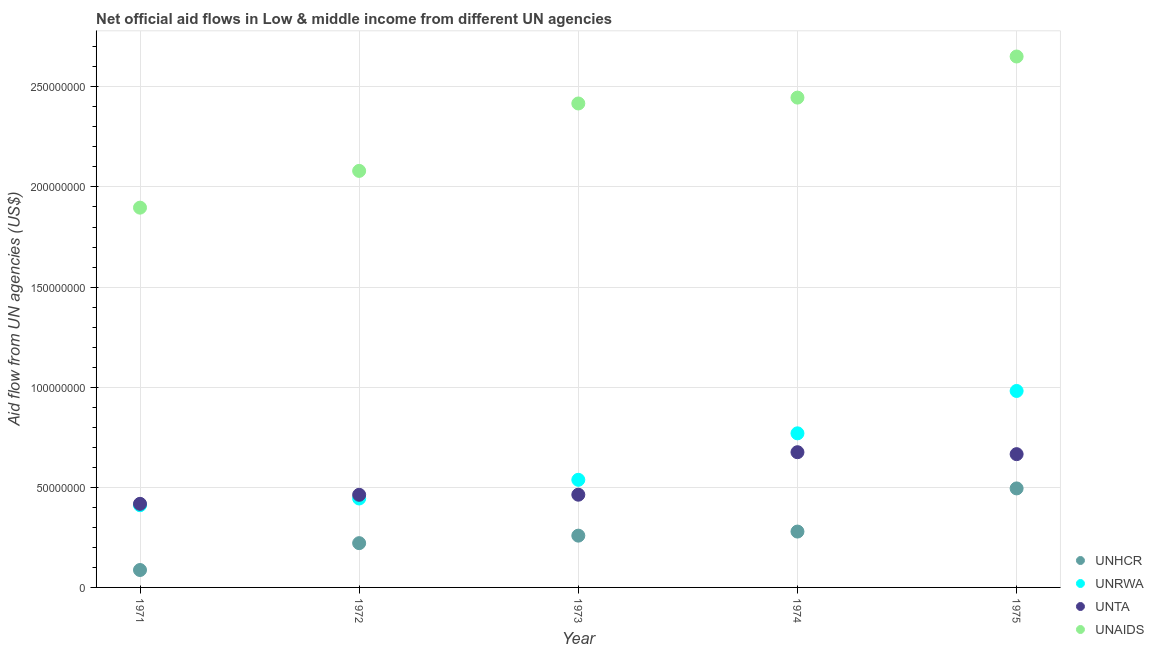How many different coloured dotlines are there?
Make the answer very short. 4. Is the number of dotlines equal to the number of legend labels?
Make the answer very short. Yes. What is the amount of aid given by unaids in 1975?
Keep it short and to the point. 2.65e+08. Across all years, what is the maximum amount of aid given by unrwa?
Your answer should be compact. 9.81e+07. Across all years, what is the minimum amount of aid given by unhcr?
Keep it short and to the point. 8.70e+06. In which year was the amount of aid given by unhcr maximum?
Your response must be concise. 1975. In which year was the amount of aid given by unhcr minimum?
Your response must be concise. 1971. What is the total amount of aid given by unhcr in the graph?
Your response must be concise. 1.34e+08. What is the difference between the amount of aid given by unaids in 1971 and that in 1974?
Make the answer very short. -5.50e+07. What is the difference between the amount of aid given by unrwa in 1975 and the amount of aid given by unhcr in 1972?
Offer a terse response. 7.60e+07. What is the average amount of aid given by unta per year?
Your answer should be very brief. 5.37e+07. In the year 1971, what is the difference between the amount of aid given by unhcr and amount of aid given by unrwa?
Give a very brief answer. -3.24e+07. In how many years, is the amount of aid given by unta greater than 50000000 US$?
Your answer should be very brief. 2. What is the ratio of the amount of aid given by unaids in 1973 to that in 1974?
Provide a short and direct response. 0.99. Is the amount of aid given by unhcr in 1972 less than that in 1973?
Ensure brevity in your answer.  Yes. What is the difference between the highest and the second highest amount of aid given by unhcr?
Your answer should be very brief. 2.16e+07. What is the difference between the highest and the lowest amount of aid given by unaids?
Offer a very short reply. 7.55e+07. In how many years, is the amount of aid given by unta greater than the average amount of aid given by unta taken over all years?
Your answer should be compact. 2. Is it the case that in every year, the sum of the amount of aid given by unhcr and amount of aid given by unrwa is greater than the sum of amount of aid given by unta and amount of aid given by unaids?
Ensure brevity in your answer.  No. Is the amount of aid given by unaids strictly greater than the amount of aid given by unrwa over the years?
Your answer should be very brief. Yes. Is the amount of aid given by unhcr strictly less than the amount of aid given by unta over the years?
Offer a very short reply. Yes. How many dotlines are there?
Offer a very short reply. 4. How many years are there in the graph?
Offer a very short reply. 5. What is the difference between two consecutive major ticks on the Y-axis?
Ensure brevity in your answer.  5.00e+07. Are the values on the major ticks of Y-axis written in scientific E-notation?
Your answer should be very brief. No. Where does the legend appear in the graph?
Offer a very short reply. Bottom right. How many legend labels are there?
Give a very brief answer. 4. How are the legend labels stacked?
Your response must be concise. Vertical. What is the title of the graph?
Keep it short and to the point. Net official aid flows in Low & middle income from different UN agencies. Does "Compensation of employees" appear as one of the legend labels in the graph?
Offer a very short reply. No. What is the label or title of the X-axis?
Make the answer very short. Year. What is the label or title of the Y-axis?
Make the answer very short. Aid flow from UN agencies (US$). What is the Aid flow from UN agencies (US$) in UNHCR in 1971?
Ensure brevity in your answer.  8.70e+06. What is the Aid flow from UN agencies (US$) of UNRWA in 1971?
Your response must be concise. 4.11e+07. What is the Aid flow from UN agencies (US$) of UNTA in 1971?
Make the answer very short. 4.18e+07. What is the Aid flow from UN agencies (US$) of UNAIDS in 1971?
Give a very brief answer. 1.90e+08. What is the Aid flow from UN agencies (US$) in UNHCR in 1972?
Keep it short and to the point. 2.21e+07. What is the Aid flow from UN agencies (US$) of UNRWA in 1972?
Make the answer very short. 4.44e+07. What is the Aid flow from UN agencies (US$) of UNTA in 1972?
Make the answer very short. 4.63e+07. What is the Aid flow from UN agencies (US$) in UNAIDS in 1972?
Your answer should be very brief. 2.08e+08. What is the Aid flow from UN agencies (US$) of UNHCR in 1973?
Your answer should be very brief. 2.59e+07. What is the Aid flow from UN agencies (US$) in UNRWA in 1973?
Your answer should be very brief. 5.38e+07. What is the Aid flow from UN agencies (US$) in UNTA in 1973?
Ensure brevity in your answer.  4.63e+07. What is the Aid flow from UN agencies (US$) in UNAIDS in 1973?
Offer a terse response. 2.42e+08. What is the Aid flow from UN agencies (US$) of UNHCR in 1974?
Offer a terse response. 2.79e+07. What is the Aid flow from UN agencies (US$) of UNRWA in 1974?
Offer a very short reply. 7.70e+07. What is the Aid flow from UN agencies (US$) of UNTA in 1974?
Your answer should be very brief. 6.75e+07. What is the Aid flow from UN agencies (US$) of UNAIDS in 1974?
Give a very brief answer. 2.45e+08. What is the Aid flow from UN agencies (US$) in UNHCR in 1975?
Offer a very short reply. 4.94e+07. What is the Aid flow from UN agencies (US$) of UNRWA in 1975?
Your response must be concise. 9.81e+07. What is the Aid flow from UN agencies (US$) in UNTA in 1975?
Keep it short and to the point. 6.66e+07. What is the Aid flow from UN agencies (US$) of UNAIDS in 1975?
Offer a very short reply. 2.65e+08. Across all years, what is the maximum Aid flow from UN agencies (US$) in UNHCR?
Ensure brevity in your answer.  4.94e+07. Across all years, what is the maximum Aid flow from UN agencies (US$) in UNRWA?
Your answer should be very brief. 9.81e+07. Across all years, what is the maximum Aid flow from UN agencies (US$) of UNTA?
Offer a very short reply. 6.75e+07. Across all years, what is the maximum Aid flow from UN agencies (US$) of UNAIDS?
Offer a terse response. 2.65e+08. Across all years, what is the minimum Aid flow from UN agencies (US$) in UNHCR?
Your answer should be compact. 8.70e+06. Across all years, what is the minimum Aid flow from UN agencies (US$) of UNRWA?
Provide a short and direct response. 4.11e+07. Across all years, what is the minimum Aid flow from UN agencies (US$) in UNTA?
Your answer should be compact. 4.18e+07. Across all years, what is the minimum Aid flow from UN agencies (US$) of UNAIDS?
Make the answer very short. 1.90e+08. What is the total Aid flow from UN agencies (US$) of UNHCR in the graph?
Provide a succinct answer. 1.34e+08. What is the total Aid flow from UN agencies (US$) in UNRWA in the graph?
Ensure brevity in your answer.  3.14e+08. What is the total Aid flow from UN agencies (US$) in UNTA in the graph?
Ensure brevity in your answer.  2.68e+08. What is the total Aid flow from UN agencies (US$) of UNAIDS in the graph?
Your answer should be compact. 1.15e+09. What is the difference between the Aid flow from UN agencies (US$) of UNHCR in 1971 and that in 1972?
Provide a succinct answer. -1.34e+07. What is the difference between the Aid flow from UN agencies (US$) of UNRWA in 1971 and that in 1972?
Provide a succinct answer. -3.36e+06. What is the difference between the Aid flow from UN agencies (US$) of UNTA in 1971 and that in 1972?
Make the answer very short. -4.51e+06. What is the difference between the Aid flow from UN agencies (US$) of UNAIDS in 1971 and that in 1972?
Ensure brevity in your answer.  -1.84e+07. What is the difference between the Aid flow from UN agencies (US$) in UNHCR in 1971 and that in 1973?
Ensure brevity in your answer.  -1.72e+07. What is the difference between the Aid flow from UN agencies (US$) of UNRWA in 1971 and that in 1973?
Give a very brief answer. -1.27e+07. What is the difference between the Aid flow from UN agencies (US$) in UNTA in 1971 and that in 1973?
Keep it short and to the point. -4.56e+06. What is the difference between the Aid flow from UN agencies (US$) in UNAIDS in 1971 and that in 1973?
Your answer should be compact. -5.20e+07. What is the difference between the Aid flow from UN agencies (US$) in UNHCR in 1971 and that in 1974?
Keep it short and to the point. -1.92e+07. What is the difference between the Aid flow from UN agencies (US$) of UNRWA in 1971 and that in 1974?
Your answer should be very brief. -3.59e+07. What is the difference between the Aid flow from UN agencies (US$) in UNTA in 1971 and that in 1974?
Your response must be concise. -2.58e+07. What is the difference between the Aid flow from UN agencies (US$) in UNAIDS in 1971 and that in 1974?
Keep it short and to the point. -5.50e+07. What is the difference between the Aid flow from UN agencies (US$) in UNHCR in 1971 and that in 1975?
Give a very brief answer. -4.08e+07. What is the difference between the Aid flow from UN agencies (US$) of UNRWA in 1971 and that in 1975?
Ensure brevity in your answer.  -5.71e+07. What is the difference between the Aid flow from UN agencies (US$) of UNTA in 1971 and that in 1975?
Give a very brief answer. -2.48e+07. What is the difference between the Aid flow from UN agencies (US$) in UNAIDS in 1971 and that in 1975?
Your answer should be very brief. -7.55e+07. What is the difference between the Aid flow from UN agencies (US$) in UNHCR in 1972 and that in 1973?
Ensure brevity in your answer.  -3.75e+06. What is the difference between the Aid flow from UN agencies (US$) of UNRWA in 1972 and that in 1973?
Give a very brief answer. -9.33e+06. What is the difference between the Aid flow from UN agencies (US$) in UNTA in 1972 and that in 1973?
Your response must be concise. -5.00e+04. What is the difference between the Aid flow from UN agencies (US$) of UNAIDS in 1972 and that in 1973?
Offer a very short reply. -3.37e+07. What is the difference between the Aid flow from UN agencies (US$) of UNHCR in 1972 and that in 1974?
Provide a succinct answer. -5.79e+06. What is the difference between the Aid flow from UN agencies (US$) in UNRWA in 1972 and that in 1974?
Offer a terse response. -3.25e+07. What is the difference between the Aid flow from UN agencies (US$) of UNTA in 1972 and that in 1974?
Your answer should be very brief. -2.13e+07. What is the difference between the Aid flow from UN agencies (US$) of UNAIDS in 1972 and that in 1974?
Offer a terse response. -3.66e+07. What is the difference between the Aid flow from UN agencies (US$) in UNHCR in 1972 and that in 1975?
Your response must be concise. -2.73e+07. What is the difference between the Aid flow from UN agencies (US$) in UNRWA in 1972 and that in 1975?
Your response must be concise. -5.37e+07. What is the difference between the Aid flow from UN agencies (US$) of UNTA in 1972 and that in 1975?
Give a very brief answer. -2.03e+07. What is the difference between the Aid flow from UN agencies (US$) in UNAIDS in 1972 and that in 1975?
Ensure brevity in your answer.  -5.71e+07. What is the difference between the Aid flow from UN agencies (US$) in UNHCR in 1973 and that in 1974?
Offer a terse response. -2.04e+06. What is the difference between the Aid flow from UN agencies (US$) of UNRWA in 1973 and that in 1974?
Keep it short and to the point. -2.32e+07. What is the difference between the Aid flow from UN agencies (US$) in UNTA in 1973 and that in 1974?
Offer a terse response. -2.12e+07. What is the difference between the Aid flow from UN agencies (US$) in UNAIDS in 1973 and that in 1974?
Keep it short and to the point. -2.93e+06. What is the difference between the Aid flow from UN agencies (US$) of UNHCR in 1973 and that in 1975?
Offer a very short reply. -2.36e+07. What is the difference between the Aid flow from UN agencies (US$) of UNRWA in 1973 and that in 1975?
Your response must be concise. -4.44e+07. What is the difference between the Aid flow from UN agencies (US$) in UNTA in 1973 and that in 1975?
Your answer should be compact. -2.03e+07. What is the difference between the Aid flow from UN agencies (US$) in UNAIDS in 1973 and that in 1975?
Ensure brevity in your answer.  -2.35e+07. What is the difference between the Aid flow from UN agencies (US$) in UNHCR in 1974 and that in 1975?
Give a very brief answer. -2.16e+07. What is the difference between the Aid flow from UN agencies (US$) of UNRWA in 1974 and that in 1975?
Make the answer very short. -2.12e+07. What is the difference between the Aid flow from UN agencies (US$) of UNTA in 1974 and that in 1975?
Your answer should be very brief. 9.70e+05. What is the difference between the Aid flow from UN agencies (US$) in UNAIDS in 1974 and that in 1975?
Offer a very short reply. -2.05e+07. What is the difference between the Aid flow from UN agencies (US$) of UNHCR in 1971 and the Aid flow from UN agencies (US$) of UNRWA in 1972?
Provide a short and direct response. -3.57e+07. What is the difference between the Aid flow from UN agencies (US$) in UNHCR in 1971 and the Aid flow from UN agencies (US$) in UNTA in 1972?
Give a very brief answer. -3.76e+07. What is the difference between the Aid flow from UN agencies (US$) in UNHCR in 1971 and the Aid flow from UN agencies (US$) in UNAIDS in 1972?
Provide a short and direct response. -1.99e+08. What is the difference between the Aid flow from UN agencies (US$) of UNRWA in 1971 and the Aid flow from UN agencies (US$) of UNTA in 1972?
Ensure brevity in your answer.  -5.20e+06. What is the difference between the Aid flow from UN agencies (US$) in UNRWA in 1971 and the Aid flow from UN agencies (US$) in UNAIDS in 1972?
Make the answer very short. -1.67e+08. What is the difference between the Aid flow from UN agencies (US$) of UNTA in 1971 and the Aid flow from UN agencies (US$) of UNAIDS in 1972?
Keep it short and to the point. -1.66e+08. What is the difference between the Aid flow from UN agencies (US$) of UNHCR in 1971 and the Aid flow from UN agencies (US$) of UNRWA in 1973?
Provide a short and direct response. -4.50e+07. What is the difference between the Aid flow from UN agencies (US$) of UNHCR in 1971 and the Aid flow from UN agencies (US$) of UNTA in 1973?
Keep it short and to the point. -3.76e+07. What is the difference between the Aid flow from UN agencies (US$) in UNHCR in 1971 and the Aid flow from UN agencies (US$) in UNAIDS in 1973?
Offer a terse response. -2.33e+08. What is the difference between the Aid flow from UN agencies (US$) in UNRWA in 1971 and the Aid flow from UN agencies (US$) in UNTA in 1973?
Ensure brevity in your answer.  -5.25e+06. What is the difference between the Aid flow from UN agencies (US$) in UNRWA in 1971 and the Aid flow from UN agencies (US$) in UNAIDS in 1973?
Keep it short and to the point. -2.01e+08. What is the difference between the Aid flow from UN agencies (US$) of UNTA in 1971 and the Aid flow from UN agencies (US$) of UNAIDS in 1973?
Provide a succinct answer. -2.00e+08. What is the difference between the Aid flow from UN agencies (US$) of UNHCR in 1971 and the Aid flow from UN agencies (US$) of UNRWA in 1974?
Your answer should be very brief. -6.83e+07. What is the difference between the Aid flow from UN agencies (US$) in UNHCR in 1971 and the Aid flow from UN agencies (US$) in UNTA in 1974?
Your answer should be compact. -5.88e+07. What is the difference between the Aid flow from UN agencies (US$) of UNHCR in 1971 and the Aid flow from UN agencies (US$) of UNAIDS in 1974?
Your answer should be compact. -2.36e+08. What is the difference between the Aid flow from UN agencies (US$) of UNRWA in 1971 and the Aid flow from UN agencies (US$) of UNTA in 1974?
Keep it short and to the point. -2.65e+07. What is the difference between the Aid flow from UN agencies (US$) in UNRWA in 1971 and the Aid flow from UN agencies (US$) in UNAIDS in 1974?
Your response must be concise. -2.04e+08. What is the difference between the Aid flow from UN agencies (US$) in UNTA in 1971 and the Aid flow from UN agencies (US$) in UNAIDS in 1974?
Offer a very short reply. -2.03e+08. What is the difference between the Aid flow from UN agencies (US$) of UNHCR in 1971 and the Aid flow from UN agencies (US$) of UNRWA in 1975?
Offer a terse response. -8.94e+07. What is the difference between the Aid flow from UN agencies (US$) in UNHCR in 1971 and the Aid flow from UN agencies (US$) in UNTA in 1975?
Give a very brief answer. -5.79e+07. What is the difference between the Aid flow from UN agencies (US$) in UNHCR in 1971 and the Aid flow from UN agencies (US$) in UNAIDS in 1975?
Offer a terse response. -2.56e+08. What is the difference between the Aid flow from UN agencies (US$) of UNRWA in 1971 and the Aid flow from UN agencies (US$) of UNTA in 1975?
Provide a succinct answer. -2.55e+07. What is the difference between the Aid flow from UN agencies (US$) of UNRWA in 1971 and the Aid flow from UN agencies (US$) of UNAIDS in 1975?
Your response must be concise. -2.24e+08. What is the difference between the Aid flow from UN agencies (US$) in UNTA in 1971 and the Aid flow from UN agencies (US$) in UNAIDS in 1975?
Offer a very short reply. -2.23e+08. What is the difference between the Aid flow from UN agencies (US$) in UNHCR in 1972 and the Aid flow from UN agencies (US$) in UNRWA in 1973?
Your response must be concise. -3.16e+07. What is the difference between the Aid flow from UN agencies (US$) of UNHCR in 1972 and the Aid flow from UN agencies (US$) of UNTA in 1973?
Keep it short and to the point. -2.42e+07. What is the difference between the Aid flow from UN agencies (US$) in UNHCR in 1972 and the Aid flow from UN agencies (US$) in UNAIDS in 1973?
Your answer should be very brief. -2.20e+08. What is the difference between the Aid flow from UN agencies (US$) in UNRWA in 1972 and the Aid flow from UN agencies (US$) in UNTA in 1973?
Provide a short and direct response. -1.89e+06. What is the difference between the Aid flow from UN agencies (US$) of UNRWA in 1972 and the Aid flow from UN agencies (US$) of UNAIDS in 1973?
Ensure brevity in your answer.  -1.97e+08. What is the difference between the Aid flow from UN agencies (US$) in UNTA in 1972 and the Aid flow from UN agencies (US$) in UNAIDS in 1973?
Offer a terse response. -1.95e+08. What is the difference between the Aid flow from UN agencies (US$) in UNHCR in 1972 and the Aid flow from UN agencies (US$) in UNRWA in 1974?
Offer a very short reply. -5.48e+07. What is the difference between the Aid flow from UN agencies (US$) in UNHCR in 1972 and the Aid flow from UN agencies (US$) in UNTA in 1974?
Make the answer very short. -4.54e+07. What is the difference between the Aid flow from UN agencies (US$) in UNHCR in 1972 and the Aid flow from UN agencies (US$) in UNAIDS in 1974?
Keep it short and to the point. -2.23e+08. What is the difference between the Aid flow from UN agencies (US$) in UNRWA in 1972 and the Aid flow from UN agencies (US$) in UNTA in 1974?
Keep it short and to the point. -2.31e+07. What is the difference between the Aid flow from UN agencies (US$) in UNRWA in 1972 and the Aid flow from UN agencies (US$) in UNAIDS in 1974?
Ensure brevity in your answer.  -2.00e+08. What is the difference between the Aid flow from UN agencies (US$) of UNTA in 1972 and the Aid flow from UN agencies (US$) of UNAIDS in 1974?
Offer a terse response. -1.98e+08. What is the difference between the Aid flow from UN agencies (US$) of UNHCR in 1972 and the Aid flow from UN agencies (US$) of UNRWA in 1975?
Make the answer very short. -7.60e+07. What is the difference between the Aid flow from UN agencies (US$) of UNHCR in 1972 and the Aid flow from UN agencies (US$) of UNTA in 1975?
Provide a short and direct response. -4.45e+07. What is the difference between the Aid flow from UN agencies (US$) in UNHCR in 1972 and the Aid flow from UN agencies (US$) in UNAIDS in 1975?
Offer a terse response. -2.43e+08. What is the difference between the Aid flow from UN agencies (US$) of UNRWA in 1972 and the Aid flow from UN agencies (US$) of UNTA in 1975?
Provide a succinct answer. -2.21e+07. What is the difference between the Aid flow from UN agencies (US$) in UNRWA in 1972 and the Aid flow from UN agencies (US$) in UNAIDS in 1975?
Ensure brevity in your answer.  -2.21e+08. What is the difference between the Aid flow from UN agencies (US$) of UNTA in 1972 and the Aid flow from UN agencies (US$) of UNAIDS in 1975?
Your answer should be very brief. -2.19e+08. What is the difference between the Aid flow from UN agencies (US$) of UNHCR in 1973 and the Aid flow from UN agencies (US$) of UNRWA in 1974?
Your response must be concise. -5.11e+07. What is the difference between the Aid flow from UN agencies (US$) of UNHCR in 1973 and the Aid flow from UN agencies (US$) of UNTA in 1974?
Keep it short and to the point. -4.17e+07. What is the difference between the Aid flow from UN agencies (US$) in UNHCR in 1973 and the Aid flow from UN agencies (US$) in UNAIDS in 1974?
Make the answer very short. -2.19e+08. What is the difference between the Aid flow from UN agencies (US$) of UNRWA in 1973 and the Aid flow from UN agencies (US$) of UNTA in 1974?
Offer a terse response. -1.38e+07. What is the difference between the Aid flow from UN agencies (US$) in UNRWA in 1973 and the Aid flow from UN agencies (US$) in UNAIDS in 1974?
Make the answer very short. -1.91e+08. What is the difference between the Aid flow from UN agencies (US$) in UNTA in 1973 and the Aid flow from UN agencies (US$) in UNAIDS in 1974?
Offer a very short reply. -1.98e+08. What is the difference between the Aid flow from UN agencies (US$) of UNHCR in 1973 and the Aid flow from UN agencies (US$) of UNRWA in 1975?
Keep it short and to the point. -7.23e+07. What is the difference between the Aid flow from UN agencies (US$) of UNHCR in 1973 and the Aid flow from UN agencies (US$) of UNTA in 1975?
Make the answer very short. -4.07e+07. What is the difference between the Aid flow from UN agencies (US$) in UNHCR in 1973 and the Aid flow from UN agencies (US$) in UNAIDS in 1975?
Your response must be concise. -2.39e+08. What is the difference between the Aid flow from UN agencies (US$) of UNRWA in 1973 and the Aid flow from UN agencies (US$) of UNTA in 1975?
Your response must be concise. -1.28e+07. What is the difference between the Aid flow from UN agencies (US$) of UNRWA in 1973 and the Aid flow from UN agencies (US$) of UNAIDS in 1975?
Your answer should be compact. -2.11e+08. What is the difference between the Aid flow from UN agencies (US$) of UNTA in 1973 and the Aid flow from UN agencies (US$) of UNAIDS in 1975?
Keep it short and to the point. -2.19e+08. What is the difference between the Aid flow from UN agencies (US$) in UNHCR in 1974 and the Aid flow from UN agencies (US$) in UNRWA in 1975?
Your answer should be very brief. -7.02e+07. What is the difference between the Aid flow from UN agencies (US$) of UNHCR in 1974 and the Aid flow from UN agencies (US$) of UNTA in 1975?
Provide a succinct answer. -3.87e+07. What is the difference between the Aid flow from UN agencies (US$) in UNHCR in 1974 and the Aid flow from UN agencies (US$) in UNAIDS in 1975?
Your answer should be compact. -2.37e+08. What is the difference between the Aid flow from UN agencies (US$) of UNRWA in 1974 and the Aid flow from UN agencies (US$) of UNTA in 1975?
Provide a short and direct response. 1.04e+07. What is the difference between the Aid flow from UN agencies (US$) of UNRWA in 1974 and the Aid flow from UN agencies (US$) of UNAIDS in 1975?
Make the answer very short. -1.88e+08. What is the difference between the Aid flow from UN agencies (US$) of UNTA in 1974 and the Aid flow from UN agencies (US$) of UNAIDS in 1975?
Ensure brevity in your answer.  -1.98e+08. What is the average Aid flow from UN agencies (US$) of UNHCR per year?
Your response must be concise. 2.68e+07. What is the average Aid flow from UN agencies (US$) of UNRWA per year?
Give a very brief answer. 6.29e+07. What is the average Aid flow from UN agencies (US$) of UNTA per year?
Keep it short and to the point. 5.37e+07. What is the average Aid flow from UN agencies (US$) in UNAIDS per year?
Ensure brevity in your answer.  2.30e+08. In the year 1971, what is the difference between the Aid flow from UN agencies (US$) of UNHCR and Aid flow from UN agencies (US$) of UNRWA?
Your response must be concise. -3.24e+07. In the year 1971, what is the difference between the Aid flow from UN agencies (US$) in UNHCR and Aid flow from UN agencies (US$) in UNTA?
Make the answer very short. -3.30e+07. In the year 1971, what is the difference between the Aid flow from UN agencies (US$) in UNHCR and Aid flow from UN agencies (US$) in UNAIDS?
Provide a short and direct response. -1.81e+08. In the year 1971, what is the difference between the Aid flow from UN agencies (US$) of UNRWA and Aid flow from UN agencies (US$) of UNTA?
Offer a terse response. -6.90e+05. In the year 1971, what is the difference between the Aid flow from UN agencies (US$) in UNRWA and Aid flow from UN agencies (US$) in UNAIDS?
Offer a very short reply. -1.49e+08. In the year 1971, what is the difference between the Aid flow from UN agencies (US$) in UNTA and Aid flow from UN agencies (US$) in UNAIDS?
Give a very brief answer. -1.48e+08. In the year 1972, what is the difference between the Aid flow from UN agencies (US$) in UNHCR and Aid flow from UN agencies (US$) in UNRWA?
Provide a short and direct response. -2.23e+07. In the year 1972, what is the difference between the Aid flow from UN agencies (US$) of UNHCR and Aid flow from UN agencies (US$) of UNTA?
Provide a short and direct response. -2.42e+07. In the year 1972, what is the difference between the Aid flow from UN agencies (US$) of UNHCR and Aid flow from UN agencies (US$) of UNAIDS?
Provide a short and direct response. -1.86e+08. In the year 1972, what is the difference between the Aid flow from UN agencies (US$) of UNRWA and Aid flow from UN agencies (US$) of UNTA?
Make the answer very short. -1.84e+06. In the year 1972, what is the difference between the Aid flow from UN agencies (US$) of UNRWA and Aid flow from UN agencies (US$) of UNAIDS?
Offer a terse response. -1.64e+08. In the year 1972, what is the difference between the Aid flow from UN agencies (US$) of UNTA and Aid flow from UN agencies (US$) of UNAIDS?
Your answer should be compact. -1.62e+08. In the year 1973, what is the difference between the Aid flow from UN agencies (US$) of UNHCR and Aid flow from UN agencies (US$) of UNRWA?
Give a very brief answer. -2.79e+07. In the year 1973, what is the difference between the Aid flow from UN agencies (US$) of UNHCR and Aid flow from UN agencies (US$) of UNTA?
Your answer should be compact. -2.04e+07. In the year 1973, what is the difference between the Aid flow from UN agencies (US$) of UNHCR and Aid flow from UN agencies (US$) of UNAIDS?
Provide a short and direct response. -2.16e+08. In the year 1973, what is the difference between the Aid flow from UN agencies (US$) of UNRWA and Aid flow from UN agencies (US$) of UNTA?
Provide a succinct answer. 7.44e+06. In the year 1973, what is the difference between the Aid flow from UN agencies (US$) of UNRWA and Aid flow from UN agencies (US$) of UNAIDS?
Your answer should be very brief. -1.88e+08. In the year 1973, what is the difference between the Aid flow from UN agencies (US$) of UNTA and Aid flow from UN agencies (US$) of UNAIDS?
Offer a terse response. -1.95e+08. In the year 1974, what is the difference between the Aid flow from UN agencies (US$) of UNHCR and Aid flow from UN agencies (US$) of UNRWA?
Offer a very short reply. -4.91e+07. In the year 1974, what is the difference between the Aid flow from UN agencies (US$) in UNHCR and Aid flow from UN agencies (US$) in UNTA?
Provide a succinct answer. -3.96e+07. In the year 1974, what is the difference between the Aid flow from UN agencies (US$) in UNHCR and Aid flow from UN agencies (US$) in UNAIDS?
Offer a terse response. -2.17e+08. In the year 1974, what is the difference between the Aid flow from UN agencies (US$) in UNRWA and Aid flow from UN agencies (US$) in UNTA?
Give a very brief answer. 9.43e+06. In the year 1974, what is the difference between the Aid flow from UN agencies (US$) in UNRWA and Aid flow from UN agencies (US$) in UNAIDS?
Your answer should be compact. -1.68e+08. In the year 1974, what is the difference between the Aid flow from UN agencies (US$) of UNTA and Aid flow from UN agencies (US$) of UNAIDS?
Your answer should be compact. -1.77e+08. In the year 1975, what is the difference between the Aid flow from UN agencies (US$) in UNHCR and Aid flow from UN agencies (US$) in UNRWA?
Your answer should be very brief. -4.87e+07. In the year 1975, what is the difference between the Aid flow from UN agencies (US$) in UNHCR and Aid flow from UN agencies (US$) in UNTA?
Offer a terse response. -1.71e+07. In the year 1975, what is the difference between the Aid flow from UN agencies (US$) in UNHCR and Aid flow from UN agencies (US$) in UNAIDS?
Provide a short and direct response. -2.16e+08. In the year 1975, what is the difference between the Aid flow from UN agencies (US$) of UNRWA and Aid flow from UN agencies (US$) of UNTA?
Give a very brief answer. 3.16e+07. In the year 1975, what is the difference between the Aid flow from UN agencies (US$) in UNRWA and Aid flow from UN agencies (US$) in UNAIDS?
Your answer should be compact. -1.67e+08. In the year 1975, what is the difference between the Aid flow from UN agencies (US$) of UNTA and Aid flow from UN agencies (US$) of UNAIDS?
Offer a very short reply. -1.99e+08. What is the ratio of the Aid flow from UN agencies (US$) in UNHCR in 1971 to that in 1972?
Ensure brevity in your answer.  0.39. What is the ratio of the Aid flow from UN agencies (US$) of UNRWA in 1971 to that in 1972?
Your response must be concise. 0.92. What is the ratio of the Aid flow from UN agencies (US$) of UNTA in 1971 to that in 1972?
Your answer should be very brief. 0.9. What is the ratio of the Aid flow from UN agencies (US$) in UNAIDS in 1971 to that in 1972?
Keep it short and to the point. 0.91. What is the ratio of the Aid flow from UN agencies (US$) in UNHCR in 1971 to that in 1973?
Provide a short and direct response. 0.34. What is the ratio of the Aid flow from UN agencies (US$) in UNRWA in 1971 to that in 1973?
Give a very brief answer. 0.76. What is the ratio of the Aid flow from UN agencies (US$) of UNTA in 1971 to that in 1973?
Your answer should be compact. 0.9. What is the ratio of the Aid flow from UN agencies (US$) in UNAIDS in 1971 to that in 1973?
Give a very brief answer. 0.78. What is the ratio of the Aid flow from UN agencies (US$) in UNHCR in 1971 to that in 1974?
Keep it short and to the point. 0.31. What is the ratio of the Aid flow from UN agencies (US$) in UNRWA in 1971 to that in 1974?
Provide a succinct answer. 0.53. What is the ratio of the Aid flow from UN agencies (US$) of UNTA in 1971 to that in 1974?
Give a very brief answer. 0.62. What is the ratio of the Aid flow from UN agencies (US$) in UNAIDS in 1971 to that in 1974?
Provide a succinct answer. 0.78. What is the ratio of the Aid flow from UN agencies (US$) of UNHCR in 1971 to that in 1975?
Offer a terse response. 0.18. What is the ratio of the Aid flow from UN agencies (US$) of UNRWA in 1971 to that in 1975?
Your answer should be compact. 0.42. What is the ratio of the Aid flow from UN agencies (US$) in UNTA in 1971 to that in 1975?
Ensure brevity in your answer.  0.63. What is the ratio of the Aid flow from UN agencies (US$) of UNAIDS in 1971 to that in 1975?
Your answer should be very brief. 0.72. What is the ratio of the Aid flow from UN agencies (US$) of UNHCR in 1972 to that in 1973?
Offer a very short reply. 0.85. What is the ratio of the Aid flow from UN agencies (US$) in UNRWA in 1972 to that in 1973?
Your response must be concise. 0.83. What is the ratio of the Aid flow from UN agencies (US$) of UNTA in 1972 to that in 1973?
Your answer should be compact. 1. What is the ratio of the Aid flow from UN agencies (US$) of UNAIDS in 1972 to that in 1973?
Provide a short and direct response. 0.86. What is the ratio of the Aid flow from UN agencies (US$) in UNHCR in 1972 to that in 1974?
Make the answer very short. 0.79. What is the ratio of the Aid flow from UN agencies (US$) in UNRWA in 1972 to that in 1974?
Offer a terse response. 0.58. What is the ratio of the Aid flow from UN agencies (US$) in UNTA in 1972 to that in 1974?
Keep it short and to the point. 0.69. What is the ratio of the Aid flow from UN agencies (US$) of UNAIDS in 1972 to that in 1974?
Ensure brevity in your answer.  0.85. What is the ratio of the Aid flow from UN agencies (US$) of UNHCR in 1972 to that in 1975?
Provide a succinct answer. 0.45. What is the ratio of the Aid flow from UN agencies (US$) in UNRWA in 1972 to that in 1975?
Your answer should be very brief. 0.45. What is the ratio of the Aid flow from UN agencies (US$) of UNTA in 1972 to that in 1975?
Provide a short and direct response. 0.69. What is the ratio of the Aid flow from UN agencies (US$) of UNAIDS in 1972 to that in 1975?
Provide a short and direct response. 0.78. What is the ratio of the Aid flow from UN agencies (US$) of UNHCR in 1973 to that in 1974?
Provide a succinct answer. 0.93. What is the ratio of the Aid flow from UN agencies (US$) in UNRWA in 1973 to that in 1974?
Your answer should be compact. 0.7. What is the ratio of the Aid flow from UN agencies (US$) of UNTA in 1973 to that in 1974?
Offer a very short reply. 0.69. What is the ratio of the Aid flow from UN agencies (US$) in UNAIDS in 1973 to that in 1974?
Your answer should be very brief. 0.99. What is the ratio of the Aid flow from UN agencies (US$) of UNHCR in 1973 to that in 1975?
Your response must be concise. 0.52. What is the ratio of the Aid flow from UN agencies (US$) in UNRWA in 1973 to that in 1975?
Keep it short and to the point. 0.55. What is the ratio of the Aid flow from UN agencies (US$) in UNTA in 1973 to that in 1975?
Provide a succinct answer. 0.7. What is the ratio of the Aid flow from UN agencies (US$) of UNAIDS in 1973 to that in 1975?
Your answer should be very brief. 0.91. What is the ratio of the Aid flow from UN agencies (US$) in UNHCR in 1974 to that in 1975?
Give a very brief answer. 0.56. What is the ratio of the Aid flow from UN agencies (US$) in UNRWA in 1974 to that in 1975?
Keep it short and to the point. 0.78. What is the ratio of the Aid flow from UN agencies (US$) of UNTA in 1974 to that in 1975?
Offer a terse response. 1.01. What is the ratio of the Aid flow from UN agencies (US$) in UNAIDS in 1974 to that in 1975?
Provide a succinct answer. 0.92. What is the difference between the highest and the second highest Aid flow from UN agencies (US$) of UNHCR?
Offer a terse response. 2.16e+07. What is the difference between the highest and the second highest Aid flow from UN agencies (US$) in UNRWA?
Your answer should be compact. 2.12e+07. What is the difference between the highest and the second highest Aid flow from UN agencies (US$) in UNTA?
Offer a very short reply. 9.70e+05. What is the difference between the highest and the second highest Aid flow from UN agencies (US$) in UNAIDS?
Offer a terse response. 2.05e+07. What is the difference between the highest and the lowest Aid flow from UN agencies (US$) of UNHCR?
Offer a terse response. 4.08e+07. What is the difference between the highest and the lowest Aid flow from UN agencies (US$) in UNRWA?
Give a very brief answer. 5.71e+07. What is the difference between the highest and the lowest Aid flow from UN agencies (US$) of UNTA?
Provide a short and direct response. 2.58e+07. What is the difference between the highest and the lowest Aid flow from UN agencies (US$) of UNAIDS?
Give a very brief answer. 7.55e+07. 